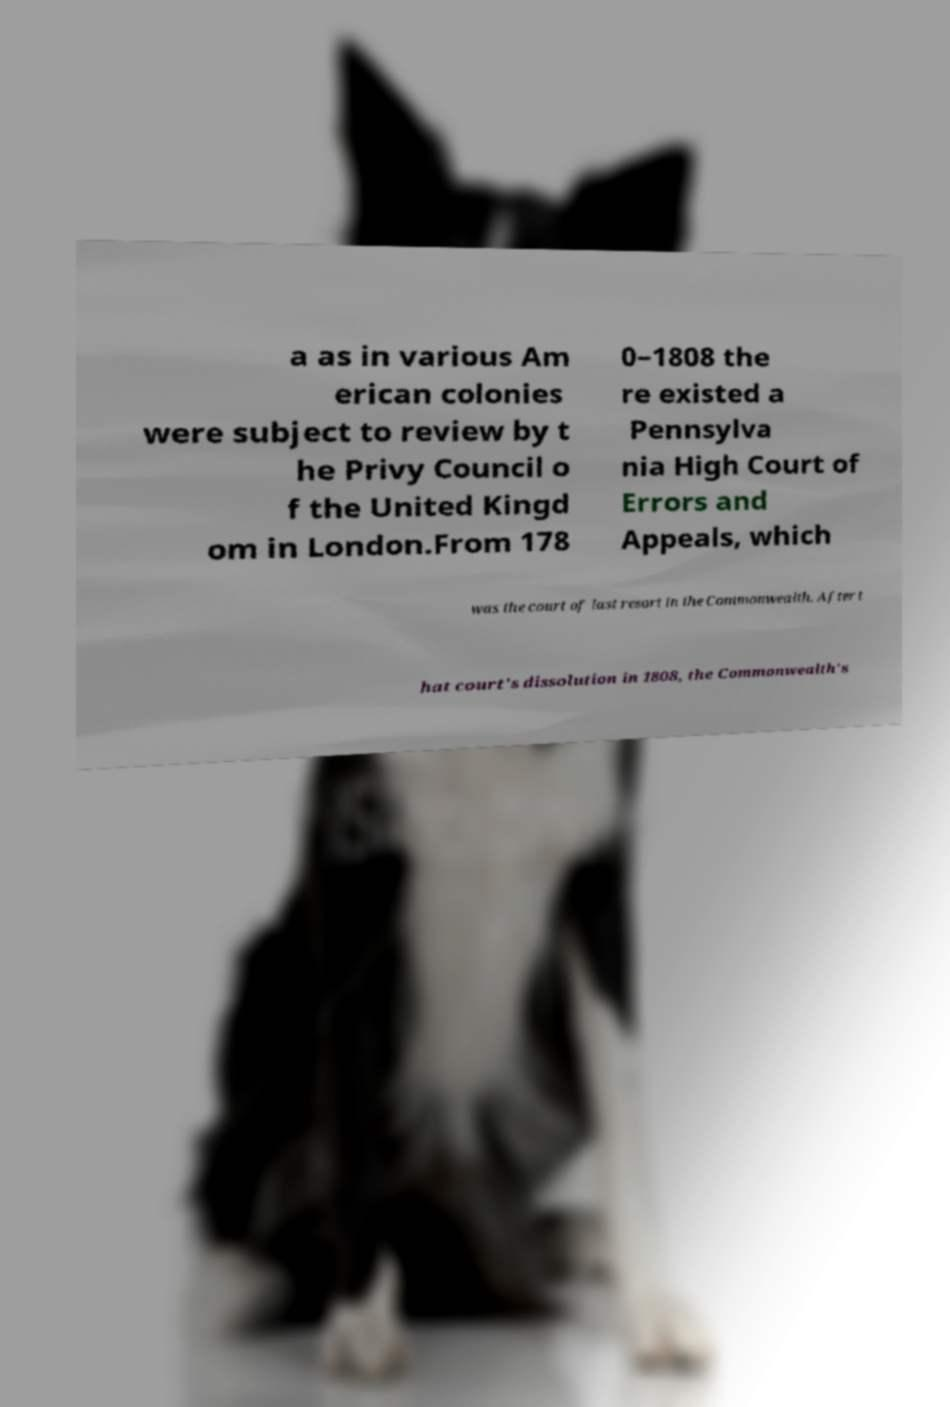Can you read and provide the text displayed in the image?This photo seems to have some interesting text. Can you extract and type it out for me? a as in various Am erican colonies were subject to review by t he Privy Council o f the United Kingd om in London.From 178 0–1808 the re existed a Pennsylva nia High Court of Errors and Appeals, which was the court of last resort in the Commonwealth. After t hat court's dissolution in 1808, the Commonwealth's 